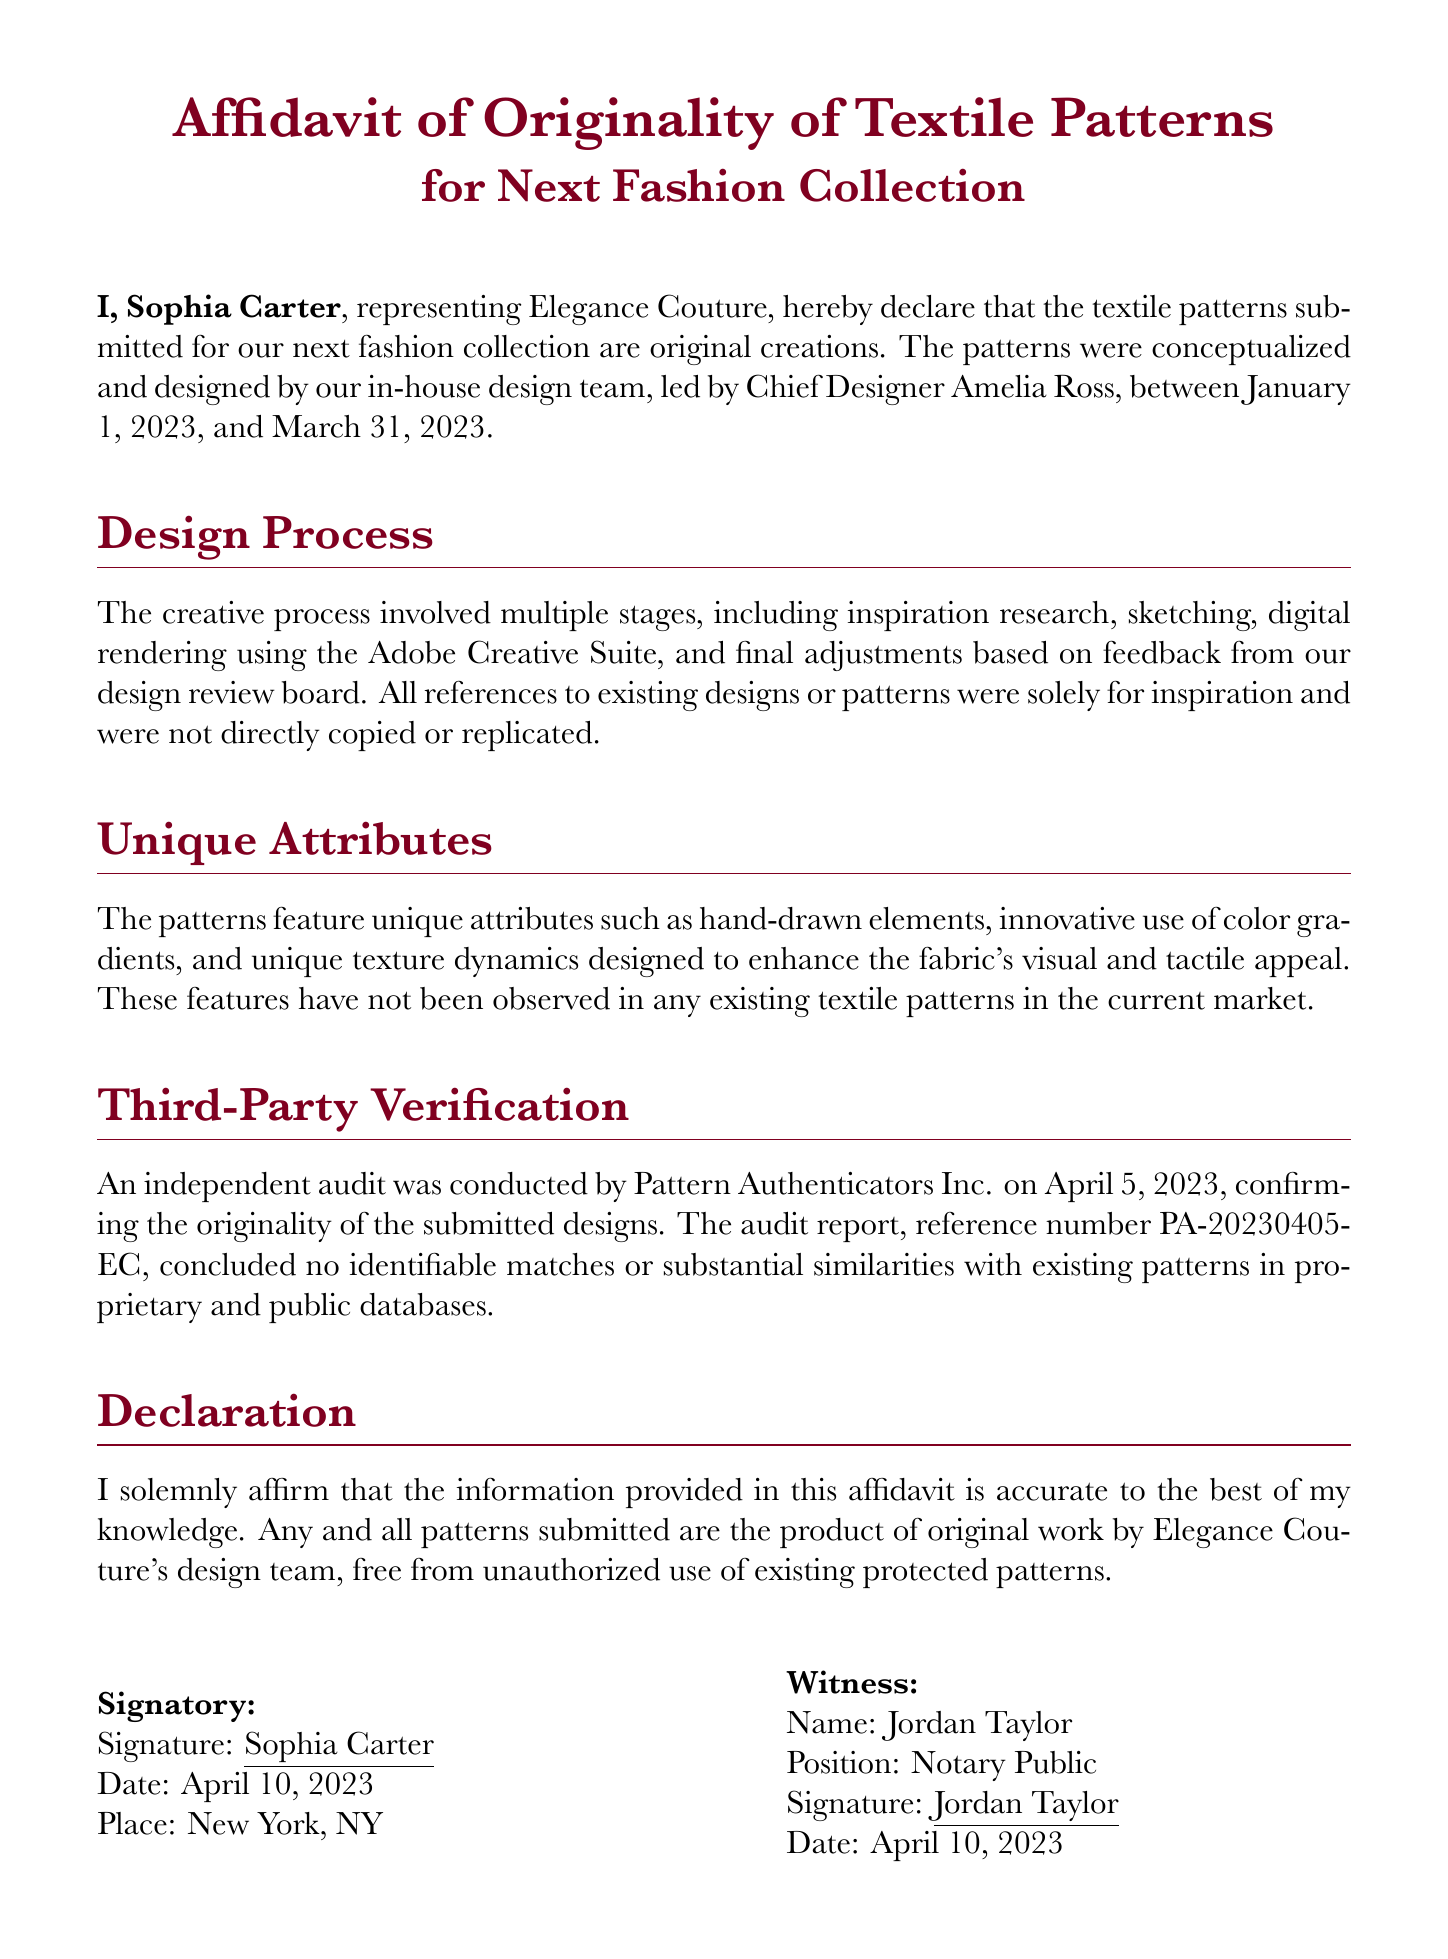What is the name of the representative? The representative's name is stated at the beginning of the document as Sophia Carter.
Answer: Sophia Carter Who is the Chief Designer? The Chief Designer's name is mentioned in the design process section.
Answer: Amelia Ross What dates were the designs created? The affidavit specifies the timeframe during which the designs were conceptualized.
Answer: January 1, 2023, to March 31, 2023 What is the audit reference number? The document provides a reference number for the audit conducted by Pattern Authenticators Inc.
Answer: PA-20230405-EC When was the affidavit signed? The date of the signature is clearly listed at the bottom of the document.
Answer: April 10, 2023 Who conducted the independent audit? The name of the company that performed the independent audit is mentioned in the document.
Answer: Pattern Authenticators Inc What city was the affidavit signed in? The place where the affidavit was signed is stated in the signatory section.
Answer: New York, NY What is stated about the originality of the designs? The document contains a declaration regarding the originality of the patterns designed.
Answer: Original creations What color scheme is used in the title section? The color of the title is described in the document.
Answer: Title color is RGB(128, 0, 32) 